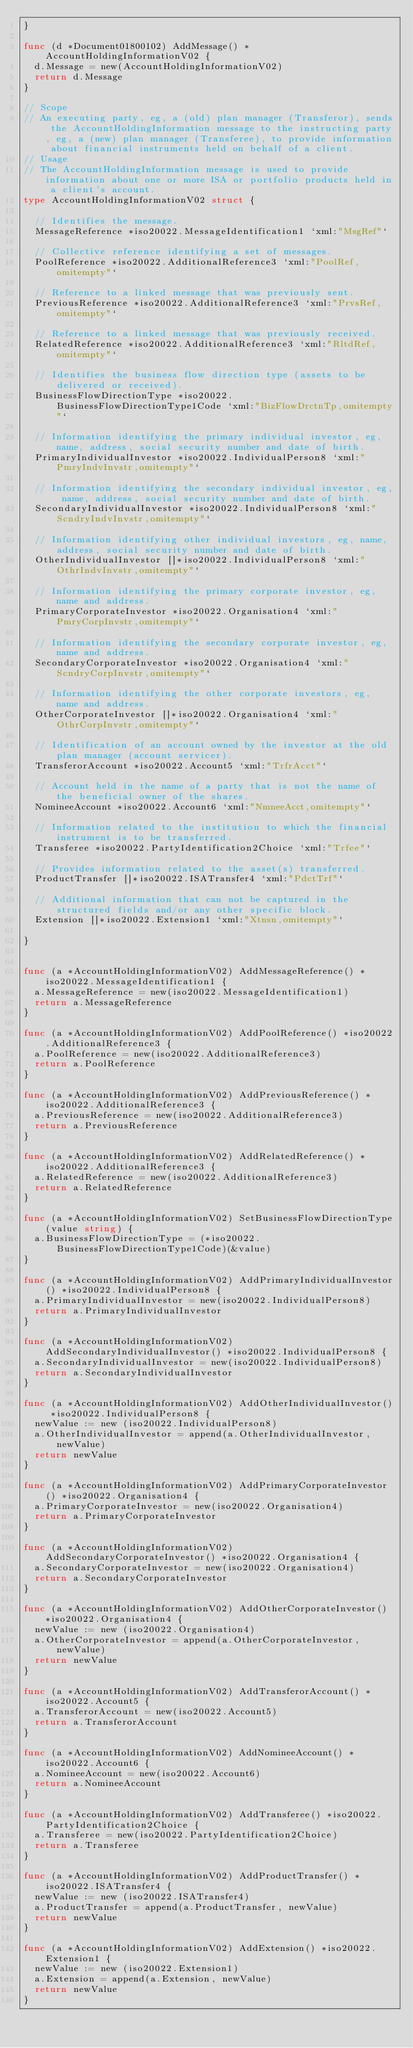<code> <loc_0><loc_0><loc_500><loc_500><_Go_>}

func (d *Document01800102) AddMessage() *AccountHoldingInformationV02 {
	d.Message = new(AccountHoldingInformationV02)
	return d.Message
}

// Scope
// An executing party, eg, a (old) plan manager (Transferor), sends the AccountHoldingInformation message to the instructing party, eg, a (new) plan manager (Transferee), to provide information about financial instruments held on behalf of a client.
// Usage
// The AccountHoldingInformation message is used to provide information about one or more ISA or portfolio products held in a client's account.
type AccountHoldingInformationV02 struct {

	// Identifies the message.
	MessageReference *iso20022.MessageIdentification1 `xml:"MsgRef"`

	// Collective reference identifying a set of messages.
	PoolReference *iso20022.AdditionalReference3 `xml:"PoolRef,omitempty"`

	// Reference to a linked message that was previously sent.
	PreviousReference *iso20022.AdditionalReference3 `xml:"PrvsRef,omitempty"`

	// Reference to a linked message that was previously received.
	RelatedReference *iso20022.AdditionalReference3 `xml:"RltdRef,omitempty"`

	// Identifies the business flow direction type (assets to be delivered or received).
	BusinessFlowDirectionType *iso20022.BusinessFlowDirectionType1Code `xml:"BizFlowDrctnTp,omitempty"`

	// Information identifying the primary individual investor, eg, name, address, social security number and date of birth.
	PrimaryIndividualInvestor *iso20022.IndividualPerson8 `xml:"PmryIndvInvstr,omitempty"`

	// Information identifying the secondary individual investor, eg, name, address, social security number and date of birth.
	SecondaryIndividualInvestor *iso20022.IndividualPerson8 `xml:"ScndryIndvInvstr,omitempty"`

	// Information identifying other individual investors, eg, name, address, social security number and date of birth.
	OtherIndividualInvestor []*iso20022.IndividualPerson8 `xml:"OthrIndvInvstr,omitempty"`

	// Information identifying the primary corporate investor, eg, name and address.
	PrimaryCorporateInvestor *iso20022.Organisation4 `xml:"PmryCorpInvstr,omitempty"`

	// Information identifying the secondary corporate investor, eg, name and address.
	SecondaryCorporateInvestor *iso20022.Organisation4 `xml:"ScndryCorpInvstr,omitempty"`

	// Information identifying the other corporate investors, eg, name and address.
	OtherCorporateInvestor []*iso20022.Organisation4 `xml:"OthrCorpInvstr,omitempty"`

	// Identification of an account owned by the investor at the old plan manager (account servicer).
	TransferorAccount *iso20022.Account5 `xml:"TrfrAcct"`

	// Account held in the name of a party that is not the name of the beneficial owner of the shares.
	NomineeAccount *iso20022.Account6 `xml:"NmneeAcct,omitempty"`

	// Information related to the institution to which the financial instrument is to be transferred.
	Transferee *iso20022.PartyIdentification2Choice `xml:"Trfee"`

	// Provides information related to the asset(s) transferred.
	ProductTransfer []*iso20022.ISATransfer4 `xml:"PdctTrf"`

	// Additional information that can not be captured in the structured fields and/or any other specific block. 
	Extension []*iso20022.Extension1 `xml:"Xtnsn,omitempty"`

}


func (a *AccountHoldingInformationV02) AddMessageReference() *iso20022.MessageIdentification1 {
	a.MessageReference = new(iso20022.MessageIdentification1)
	return a.MessageReference
}

func (a *AccountHoldingInformationV02) AddPoolReference() *iso20022.AdditionalReference3 {
	a.PoolReference = new(iso20022.AdditionalReference3)
	return a.PoolReference
}

func (a *AccountHoldingInformationV02) AddPreviousReference() *iso20022.AdditionalReference3 {
	a.PreviousReference = new(iso20022.AdditionalReference3)
	return a.PreviousReference
}

func (a *AccountHoldingInformationV02) AddRelatedReference() *iso20022.AdditionalReference3 {
	a.RelatedReference = new(iso20022.AdditionalReference3)
	return a.RelatedReference
}

func (a *AccountHoldingInformationV02) SetBusinessFlowDirectionType(value string) {
	a.BusinessFlowDirectionType = (*iso20022.BusinessFlowDirectionType1Code)(&value)
}

func (a *AccountHoldingInformationV02) AddPrimaryIndividualInvestor() *iso20022.IndividualPerson8 {
	a.PrimaryIndividualInvestor = new(iso20022.IndividualPerson8)
	return a.PrimaryIndividualInvestor
}

func (a *AccountHoldingInformationV02) AddSecondaryIndividualInvestor() *iso20022.IndividualPerson8 {
	a.SecondaryIndividualInvestor = new(iso20022.IndividualPerson8)
	return a.SecondaryIndividualInvestor
}

func (a *AccountHoldingInformationV02) AddOtherIndividualInvestor() *iso20022.IndividualPerson8 {
	newValue := new (iso20022.IndividualPerson8)
	a.OtherIndividualInvestor = append(a.OtherIndividualInvestor, newValue)
	return newValue
}

func (a *AccountHoldingInformationV02) AddPrimaryCorporateInvestor() *iso20022.Organisation4 {
	a.PrimaryCorporateInvestor = new(iso20022.Organisation4)
	return a.PrimaryCorporateInvestor
}

func (a *AccountHoldingInformationV02) AddSecondaryCorporateInvestor() *iso20022.Organisation4 {
	a.SecondaryCorporateInvestor = new(iso20022.Organisation4)
	return a.SecondaryCorporateInvestor
}

func (a *AccountHoldingInformationV02) AddOtherCorporateInvestor() *iso20022.Organisation4 {
	newValue := new (iso20022.Organisation4)
	a.OtherCorporateInvestor = append(a.OtherCorporateInvestor, newValue)
	return newValue
}

func (a *AccountHoldingInformationV02) AddTransferorAccount() *iso20022.Account5 {
	a.TransferorAccount = new(iso20022.Account5)
	return a.TransferorAccount
}

func (a *AccountHoldingInformationV02) AddNomineeAccount() *iso20022.Account6 {
	a.NomineeAccount = new(iso20022.Account6)
	return a.NomineeAccount
}

func (a *AccountHoldingInformationV02) AddTransferee() *iso20022.PartyIdentification2Choice {
	a.Transferee = new(iso20022.PartyIdentification2Choice)
	return a.Transferee
}

func (a *AccountHoldingInformationV02) AddProductTransfer() *iso20022.ISATransfer4 {
	newValue := new (iso20022.ISATransfer4)
	a.ProductTransfer = append(a.ProductTransfer, newValue)
	return newValue
}

func (a *AccountHoldingInformationV02) AddExtension() *iso20022.Extension1 {
	newValue := new (iso20022.Extension1)
	a.Extension = append(a.Extension, newValue)
	return newValue
}

</code> 